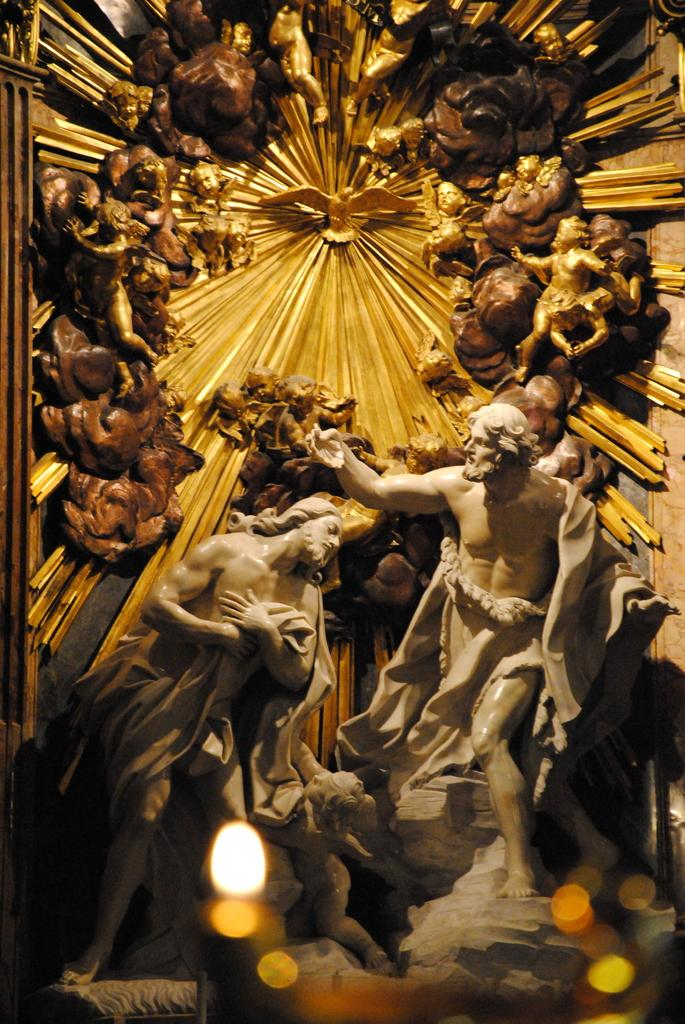What type of objects are present in the image? There are statues in the image. Can you describe the arrangement of these objects? There is a group of sculptures in the image. What type of cakes are being served at the event in the image? There is no event or cakes present in the image; it features statues and a group of sculptures. What type of apparel is the robin wearing in the image? There is no robin present in the image, and therefore no apparel can be observed. 